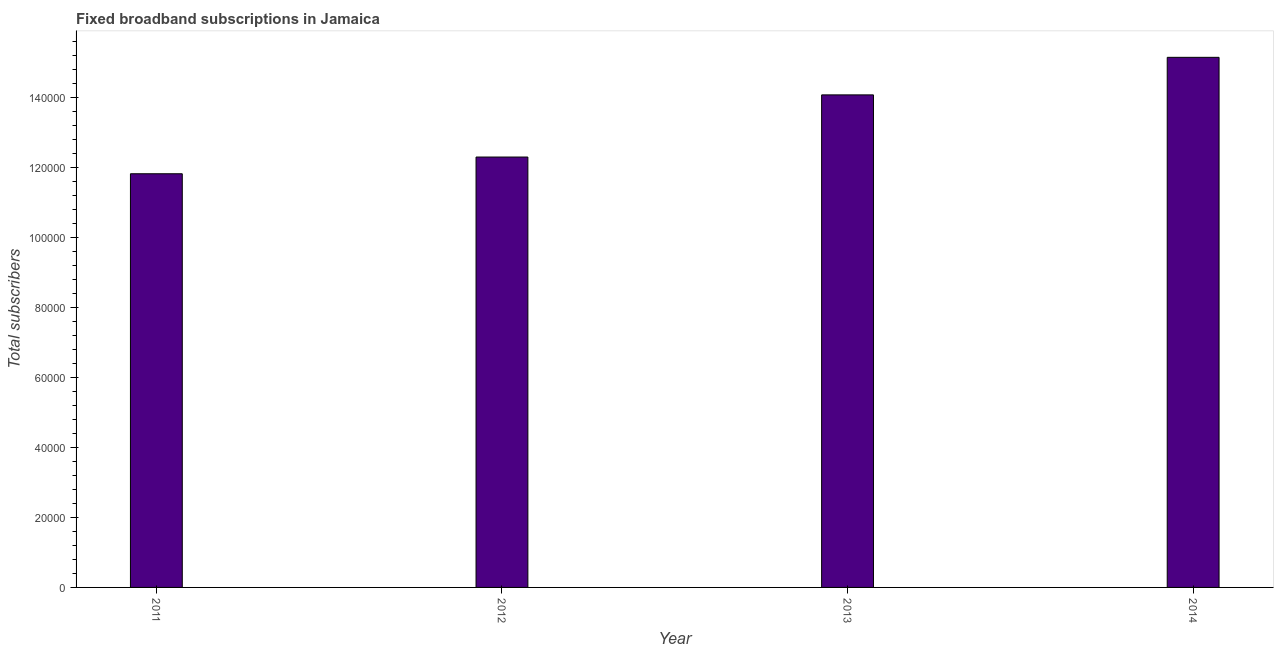Does the graph contain any zero values?
Your answer should be compact. No. What is the title of the graph?
Provide a succinct answer. Fixed broadband subscriptions in Jamaica. What is the label or title of the X-axis?
Make the answer very short. Year. What is the label or title of the Y-axis?
Provide a short and direct response. Total subscribers. What is the total number of fixed broadband subscriptions in 2011?
Ensure brevity in your answer.  1.18e+05. Across all years, what is the maximum total number of fixed broadband subscriptions?
Ensure brevity in your answer.  1.52e+05. Across all years, what is the minimum total number of fixed broadband subscriptions?
Provide a succinct answer. 1.18e+05. In which year was the total number of fixed broadband subscriptions maximum?
Provide a short and direct response. 2014. In which year was the total number of fixed broadband subscriptions minimum?
Your response must be concise. 2011. What is the sum of the total number of fixed broadband subscriptions?
Your answer should be very brief. 5.34e+05. What is the difference between the total number of fixed broadband subscriptions in 2013 and 2014?
Give a very brief answer. -1.07e+04. What is the average total number of fixed broadband subscriptions per year?
Your response must be concise. 1.33e+05. What is the median total number of fixed broadband subscriptions?
Your response must be concise. 1.32e+05. Do a majority of the years between 2011 and 2012 (inclusive) have total number of fixed broadband subscriptions greater than 88000 ?
Keep it short and to the point. Yes. What is the ratio of the total number of fixed broadband subscriptions in 2011 to that in 2014?
Make the answer very short. 0.78. What is the difference between the highest and the second highest total number of fixed broadband subscriptions?
Your answer should be compact. 1.07e+04. Is the sum of the total number of fixed broadband subscriptions in 2012 and 2014 greater than the maximum total number of fixed broadband subscriptions across all years?
Your answer should be compact. Yes. What is the difference between the highest and the lowest total number of fixed broadband subscriptions?
Your response must be concise. 3.33e+04. In how many years, is the total number of fixed broadband subscriptions greater than the average total number of fixed broadband subscriptions taken over all years?
Make the answer very short. 2. What is the difference between two consecutive major ticks on the Y-axis?
Your response must be concise. 2.00e+04. What is the Total subscribers of 2011?
Your answer should be very brief. 1.18e+05. What is the Total subscribers of 2012?
Ensure brevity in your answer.  1.23e+05. What is the Total subscribers in 2013?
Keep it short and to the point. 1.41e+05. What is the Total subscribers in 2014?
Your answer should be very brief. 1.52e+05. What is the difference between the Total subscribers in 2011 and 2012?
Provide a short and direct response. -4777. What is the difference between the Total subscribers in 2011 and 2013?
Your answer should be compact. -2.25e+04. What is the difference between the Total subscribers in 2011 and 2014?
Provide a succinct answer. -3.33e+04. What is the difference between the Total subscribers in 2012 and 2013?
Give a very brief answer. -1.78e+04. What is the difference between the Total subscribers in 2012 and 2014?
Ensure brevity in your answer.  -2.85e+04. What is the difference between the Total subscribers in 2013 and 2014?
Your answer should be very brief. -1.07e+04. What is the ratio of the Total subscribers in 2011 to that in 2012?
Keep it short and to the point. 0.96. What is the ratio of the Total subscribers in 2011 to that in 2013?
Offer a terse response. 0.84. What is the ratio of the Total subscribers in 2011 to that in 2014?
Provide a short and direct response. 0.78. What is the ratio of the Total subscribers in 2012 to that in 2013?
Give a very brief answer. 0.87. What is the ratio of the Total subscribers in 2012 to that in 2014?
Your answer should be compact. 0.81. What is the ratio of the Total subscribers in 2013 to that in 2014?
Your answer should be very brief. 0.93. 